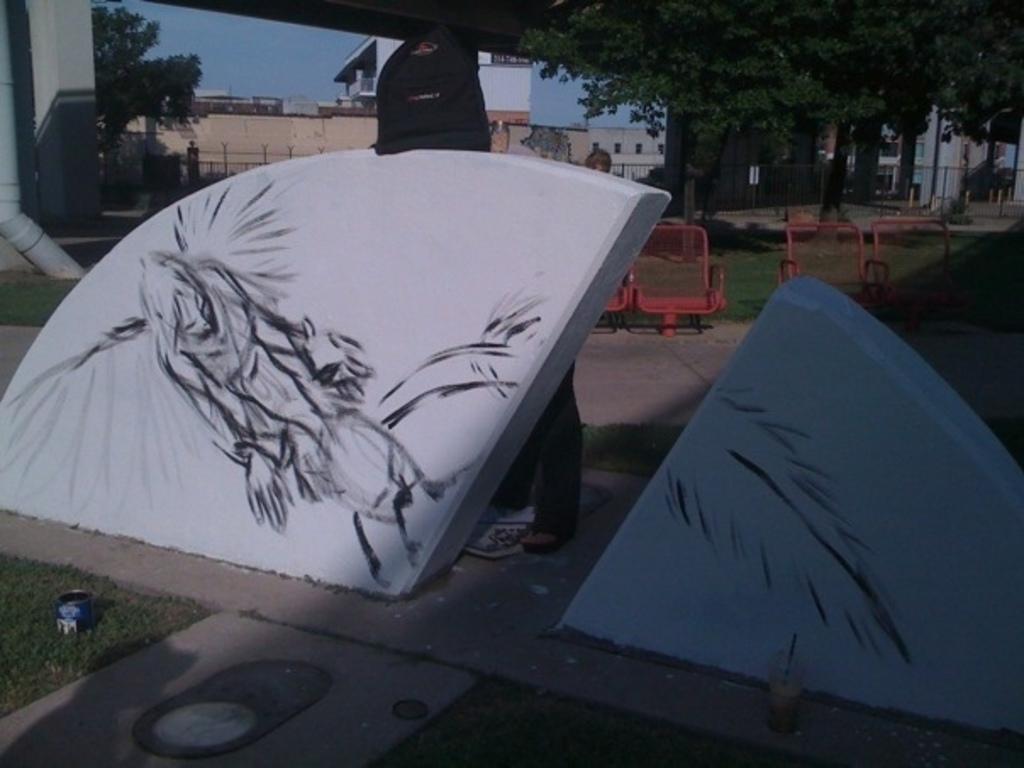Describe this image in one or two sentences. In this image I can see the ground, some grass on the ground, a white colored concrete wall, a black colored painting on it, few red colored chairs, a pipe, the railing, few trees, few building and in the background I can see the sky. 